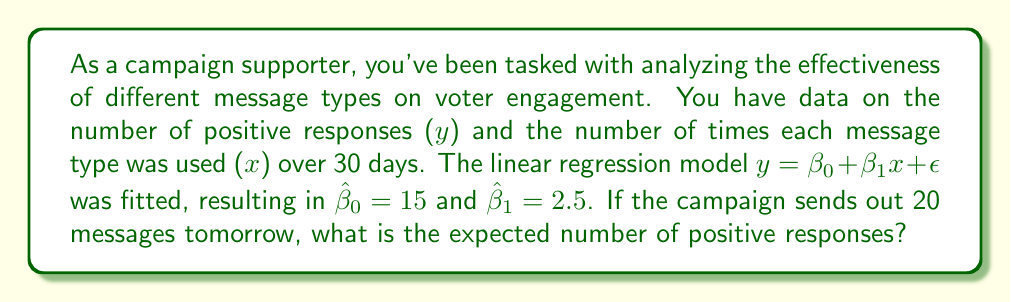Can you answer this question? To solve this problem, we'll use the fitted linear regression model to predict the number of positive responses for 20 messages. Let's break it down step-by-step:

1. The general form of the linear regression model is:
   $$y = \beta_0 + \beta_1x + \epsilon$$

2. The fitted model, without the error term, is:
   $$\hat{y} = \hat{\beta}_0 + \hat{\beta}_1x$$

3. We're given the following values:
   $\hat{\beta}_0 = 15$ (y-intercept)
   $\hat{\beta}_1 = 2.5$ (slope)
   $x = 20$ (number of messages)

4. Substituting these values into the fitted model equation:
   $$\hat{y} = 15 + 2.5(20)$$

5. Simplify:
   $$\hat{y} = 15 + 50 = 65$$

Therefore, the expected number of positive responses when sending out 20 messages is 65.
Answer: 65 positive responses 